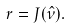<formula> <loc_0><loc_0><loc_500><loc_500>r = J ( \hat { \nu } ) .</formula> 